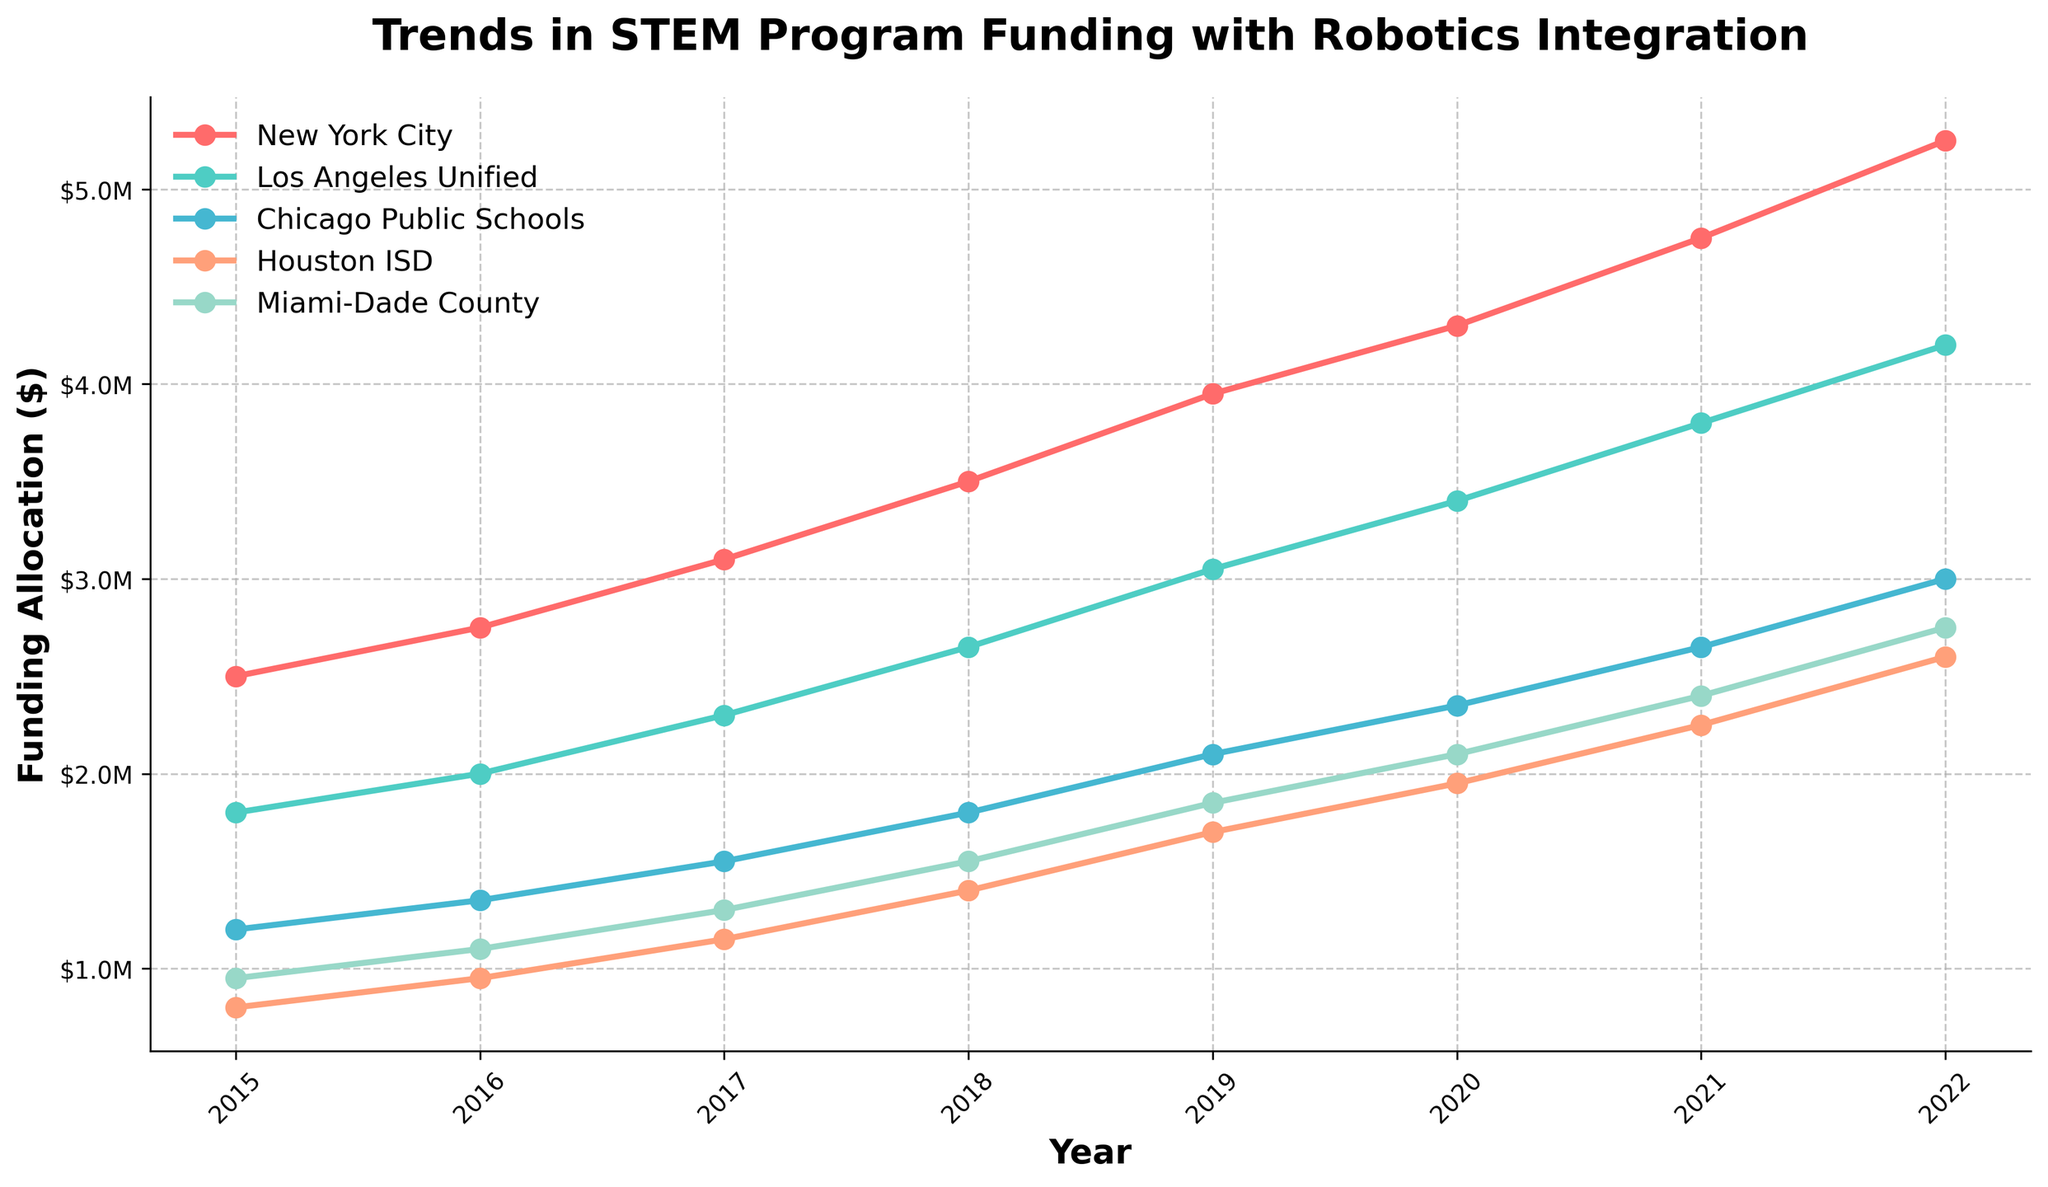What is the funding allocation for New York City in 2022? Look at the line representing New York City and find the value for the year 2022
Answer: $5.25M Which school district saw the highest increase in funding between 2015 and 2022? Calculate the increase for each district by subtracting the 2015 funding from 2022 funding, then compare the results: New York City ($5.25M - $2.5M = $2.75M), Los Angeles Unified ($4.2M - $1.8M = $2.4M), Chicago Public Schools ($3M - $1.2M = $1.8M), Houston ISD ($2.6M - $0.8M = $1.8M), Miami-Dade County ($2.75M - $0.95M = $1.8M)
Answer: New York City What is the approximate average funding for Los Angeles Unified between 2015 and 2022? Sum the yearly funding allocations (1.8M + 2M + 2.3M + 2.65M + 3.05M + 3.4M + 3.8M + 4.2M) and divide by the number of years (8): (23.2M / 8)
Answer: $2.9M Between which consecutive years did Chicago Public Schools experience the largest increase in funding? Calculate the differences for each year pair and find the largest: 2015-2016 (1.35M - 1.2M = 0.15M), 2016-2017 (1.55M - 1.35M = 0.2M), 2017-2018 (1.8M - 1.55M = 0.25M), 2018-2019 (2.1M - 1.8M = 0.3M), 2019-2020 (2.35M - 2.1M = 0.25M), 2020-2021 (2.65M - 2.35M = 0.3M), 2021-2022 (3M - 2.65M = 0.35M)
Answer: 2021-2022 Which two school districts have nearly identical funding trends over the given years? Compare the lines visually; Houston ISD and Miami-Dade County have lines that closely follow each other
Answer: Houston ISD and Miami-Dade County What color represents the funding trend for Miami-Dade County? Identify the color used for Miami-Dade County's line in the chart
Answer: Green By how much did the funding for Houston ISD change from 2019 to 2022? Subtract the 2019 funding from the 2022 funding: (2.6M - 1.7M)
Answer: $0.9M Is the funding trend for all districts increasing, decreasing, or stable over the period? Observe the slope of each line; all lines show an increasing trend over time
Answer: Increasing 